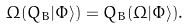<formula> <loc_0><loc_0><loc_500><loc_500>\Omega ( Q _ { B } | \Phi \rangle ) = Q _ { B } ( \Omega | \Phi \rangle ) .</formula> 